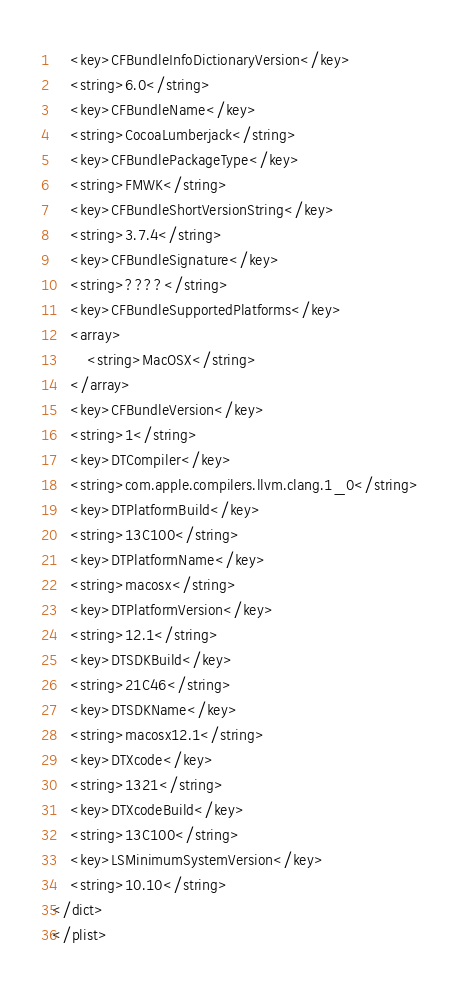Convert code to text. <code><loc_0><loc_0><loc_500><loc_500><_XML_>	<key>CFBundleInfoDictionaryVersion</key>
	<string>6.0</string>
	<key>CFBundleName</key>
	<string>CocoaLumberjack</string>
	<key>CFBundlePackageType</key>
	<string>FMWK</string>
	<key>CFBundleShortVersionString</key>
	<string>3.7.4</string>
	<key>CFBundleSignature</key>
	<string>????</string>
	<key>CFBundleSupportedPlatforms</key>
	<array>
		<string>MacOSX</string>
	</array>
	<key>CFBundleVersion</key>
	<string>1</string>
	<key>DTCompiler</key>
	<string>com.apple.compilers.llvm.clang.1_0</string>
	<key>DTPlatformBuild</key>
	<string>13C100</string>
	<key>DTPlatformName</key>
	<string>macosx</string>
	<key>DTPlatformVersion</key>
	<string>12.1</string>
	<key>DTSDKBuild</key>
	<string>21C46</string>
	<key>DTSDKName</key>
	<string>macosx12.1</string>
	<key>DTXcode</key>
	<string>1321</string>
	<key>DTXcodeBuild</key>
	<string>13C100</string>
	<key>LSMinimumSystemVersion</key>
	<string>10.10</string>
</dict>
</plist>
</code> 